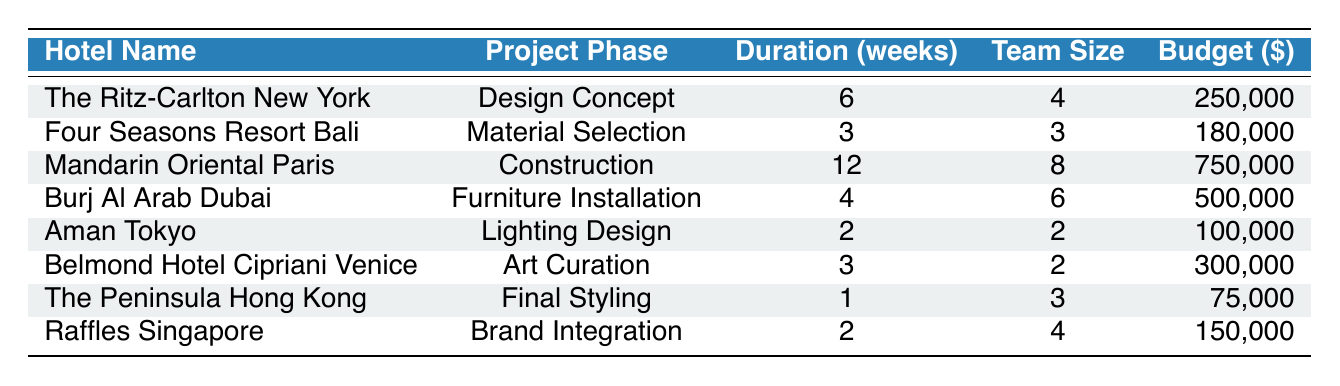What is the duration of the project phase for The Ritz-Carlton New York? The table shows that under the project phase for The Ritz-Carlton New York, the duration is listed as 6 weeks.
Answer: 6 weeks How many team members are involved in the Furniture Installation phase at Burj Al Arab Dubai? The table states that the team size for the Furniture Installation phase at Burj Al Arab Dubai is 6.
Answer: 6 Which hotel project has the highest budget allocation? The table indicates that the Mandarin Oriental Paris has the highest budget allocation at $750,000.
Answer: $750,000 What is the total duration of the project phases for Aman Tokyo and Raffles Singapore combined? The duration for Aman Tokyo is 2 weeks and for Raffles Singapore is also 2 weeks. Adding them together gives 2 + 2 = 4 weeks.
Answer: 4 weeks Is the budget allocation for Belmond Hotel Cipriani Venice greater than that of The Peninsula Hong Kong? The budget for Belmond Hotel Cipriani Venice is $300,000, while for The Peninsula Hong Kong it is $75,000. Since $300,000 is greater than $75,000, the answer is yes.
Answer: Yes What is the average duration of the project phases across all hotels listed in the table? The durations are 6, 3, 12, 4, 2, 3, 1, and 2 weeks. Their sum is 33 weeks across 8 projects. The average is 33/8 = 4.125 weeks.
Answer: 4.125 weeks How many more weeks does the Construction phase of Mandarin Oriental Paris last compared to the Final Styling of The Peninsula Hong Kong? The duration for the Construction phase is 12 weeks and for Final Styling is 1 week. The difference is 12 - 1 = 11 weeks.
Answer: 11 weeks Which hotel has the smallest team size, and what is that size? The table indicates that Aman Tokyo has the smallest team size of 2.
Answer: 2 Are there more project phases with a budget above $200,000 than those below? The projects with budgets over $200,000 are The Ritz-Carlton New York ($250,000), Mandarin Oriental Paris ($750,000), and Belmond Hotel Cipriani Venice ($300,000). That totals 3 projects, while those below $200,000 are Four Seasons Resort Bali ($180,000), Burj Al Arab Dubai ($500,000), Aman Tokyo ($100,000), The Peninsula Hong Kong ($75,000), and Raffles Singapore ($150,000). That totals 5 projects. Therefore, there are more projects below $200,000.
Answer: No What is the combined budget allocation of the Design Concept phase and the Material Selection phase? The budget for Design Concept at The Ritz-Carlton New York is $250,000, and for Material Selection at Four Seasons Resort Bali is $180,000. Adding them gives $250,000 + $180,000 = $430,000.
Answer: $430,000 